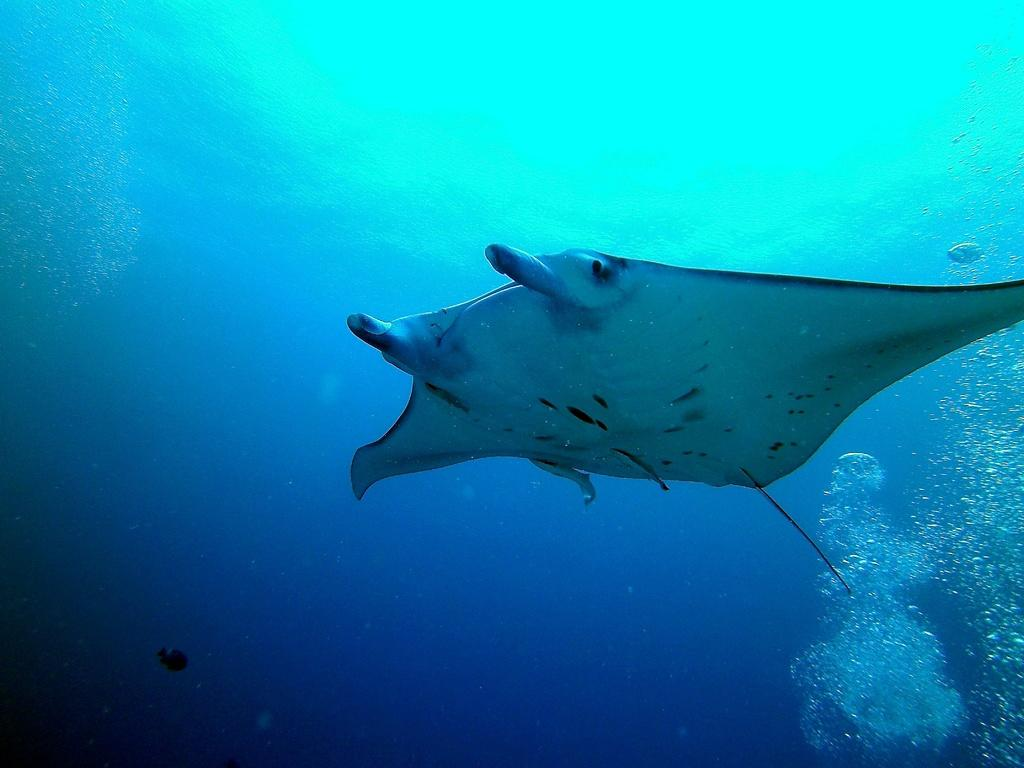What is inside the water in the image? There is a picture inside the water. What is depicted in the picture? The picture contains an aquatic animal. Can you describe the appearance of the aquatic animal? The aquatic animal is white and black in color. What else can be seen in the background of the picture? There are air bubbles in the background of the picture. Is there an island visible in the picture? No, there is no island present in the image. What type of power source is used by the aquatic animal in the picture? The image does not provide information about the power source of the aquatic animal, as it is a static picture. 